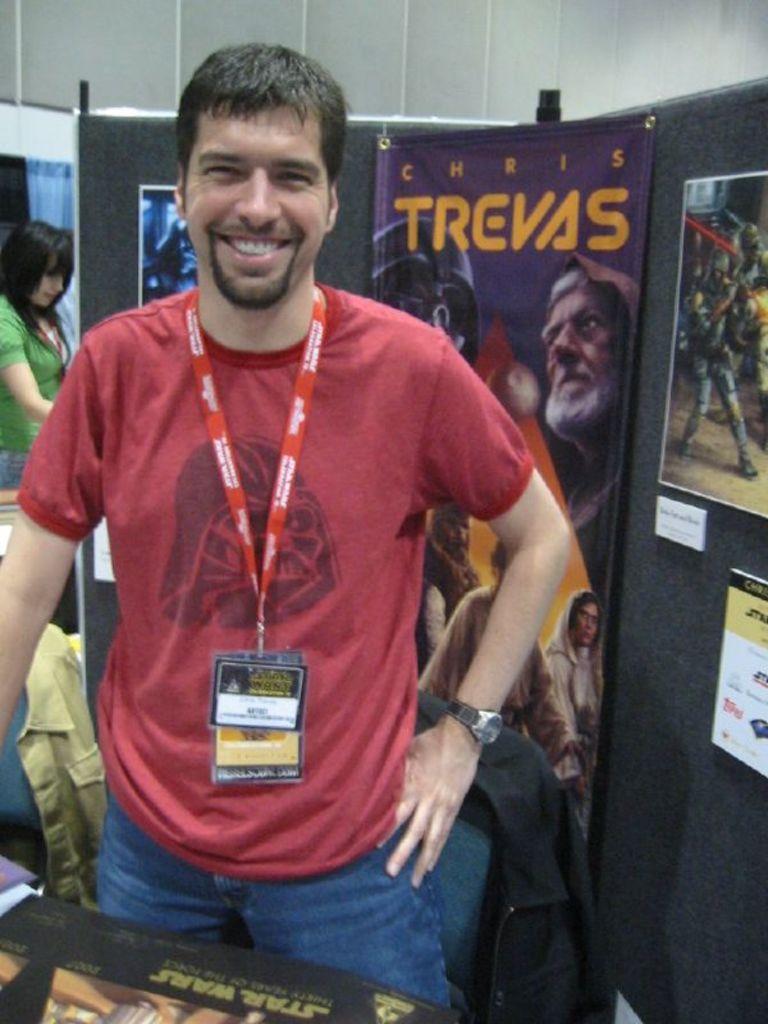What is the title on the poster behind the man?
Keep it short and to the point. Chris trevas. 